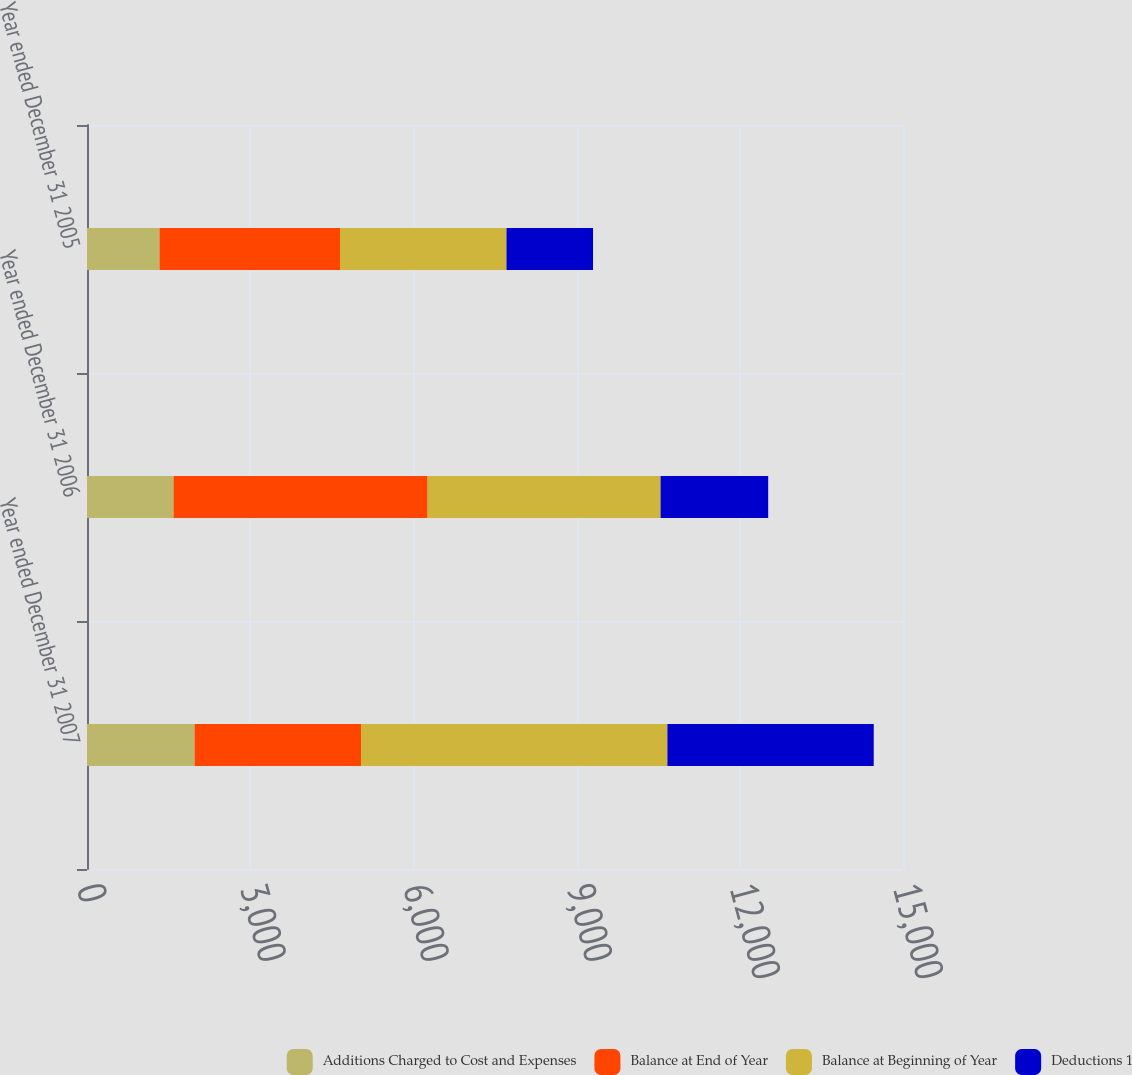Convert chart. <chart><loc_0><loc_0><loc_500><loc_500><stacked_bar_chart><ecel><fcel>Year ended December 31 2007<fcel>Year ended December 31 2006<fcel>Year ended December 31 2005<nl><fcel>Additions Charged to Cost and Expenses<fcel>1978<fcel>1591<fcel>1334<nl><fcel>Balance at End of Year<fcel>3060<fcel>4670<fcel>3317<nl><fcel>Balance at Beginning of Year<fcel>5631<fcel>4283<fcel>3060<nl><fcel>Deductions 1<fcel>3793<fcel>1978<fcel>1591<nl></chart> 